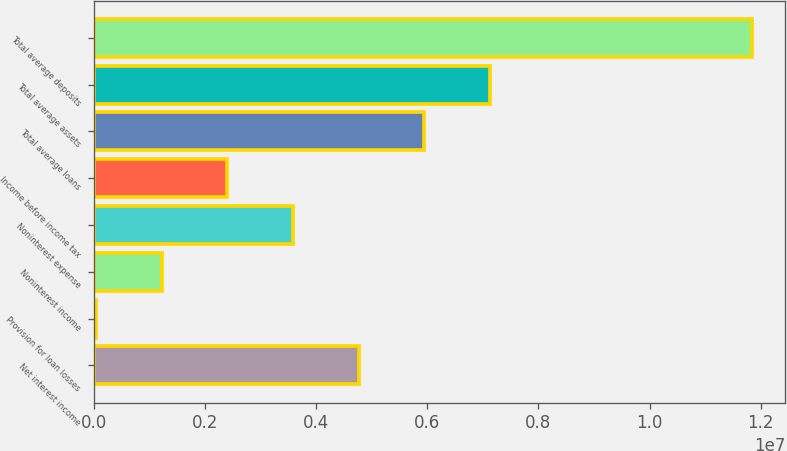<chart> <loc_0><loc_0><loc_500><loc_500><bar_chart><fcel>Net interest income<fcel>Provision for loan losses<fcel>Noninterest income<fcel>Noninterest expense<fcel>Income before income tax<fcel>Total average loans<fcel>Total average assets<fcel>Total average deposits<nl><fcel>4.76251e+06<fcel>39285<fcel>1.22009e+06<fcel>3.58171e+06<fcel>2.4009e+06<fcel>5.94332e+06<fcel>7.12413e+06<fcel>1.18474e+07<nl></chart> 